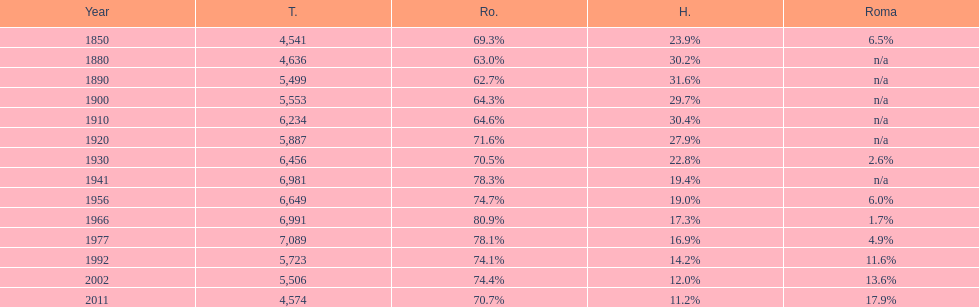What is the number of times the total population was 6,000 or more? 6. 